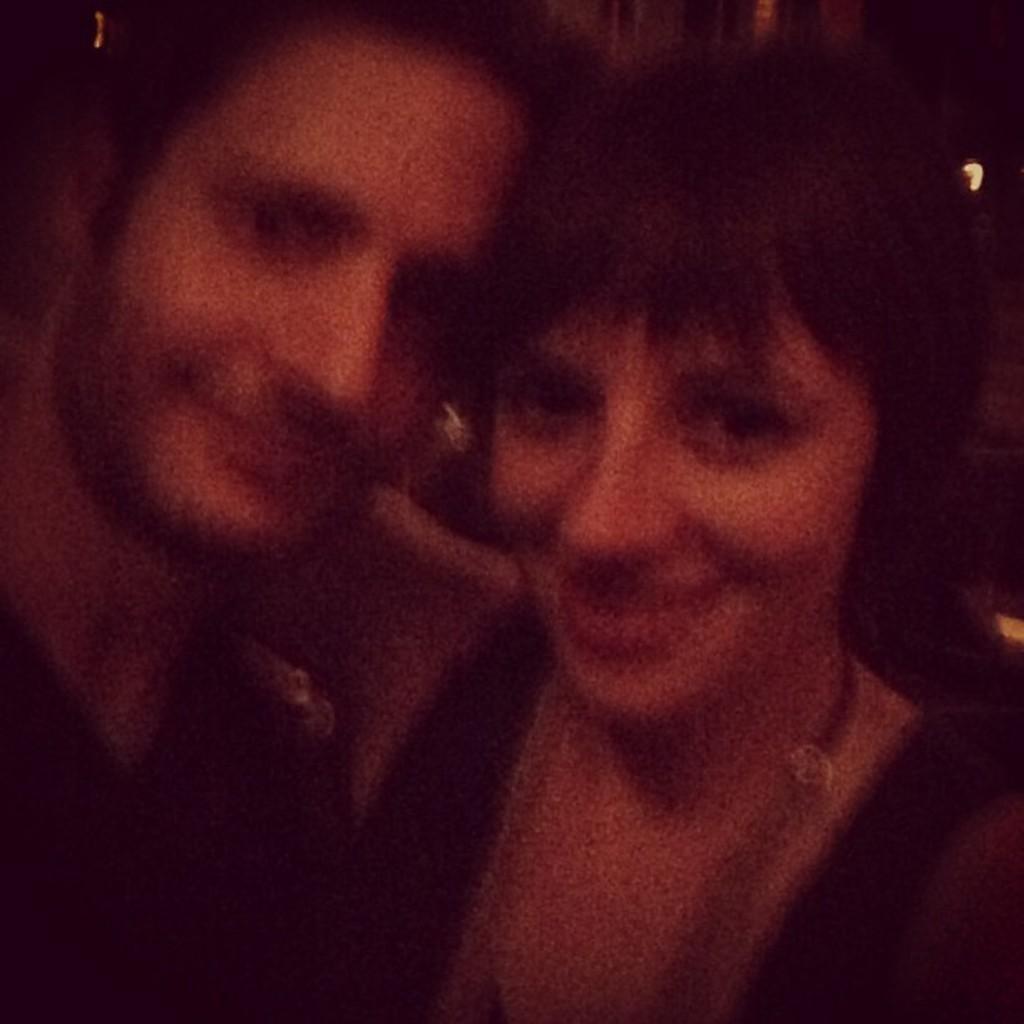Describe this image in one or two sentences. This is the picture of two people, the women and man the picture is blur and the background is in black color we can see a light. 